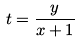<formula> <loc_0><loc_0><loc_500><loc_500>t = \frac { y } { x + 1 }</formula> 